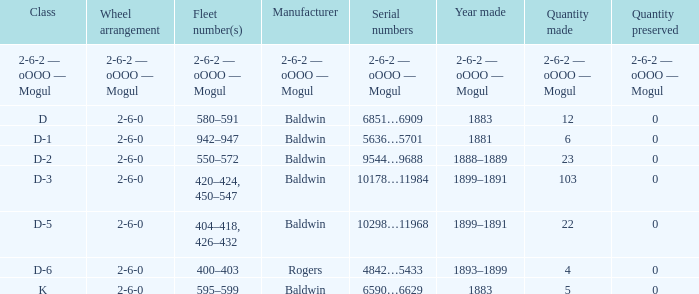What is the wheel arrangement when the year made is 1881? 2-6-0. 